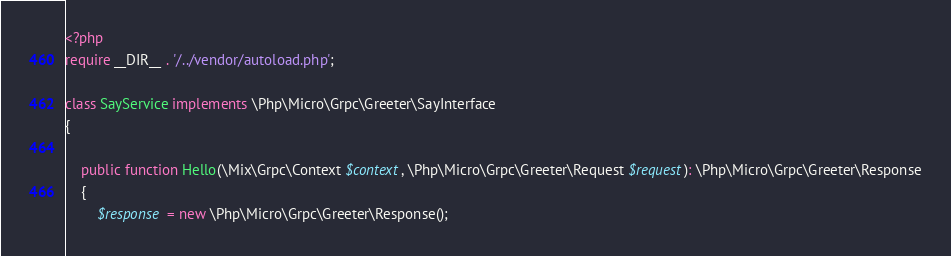<code> <loc_0><loc_0><loc_500><loc_500><_PHP_><?php
require __DIR__ . '/../vendor/autoload.php';

class SayService implements \Php\Micro\Grpc\Greeter\SayInterface
{

    public function Hello(\Mix\Grpc\Context $context, \Php\Micro\Grpc\Greeter\Request $request): \Php\Micro\Grpc\Greeter\Response
    {
        $response = new \Php\Micro\Grpc\Greeter\Response();</code> 